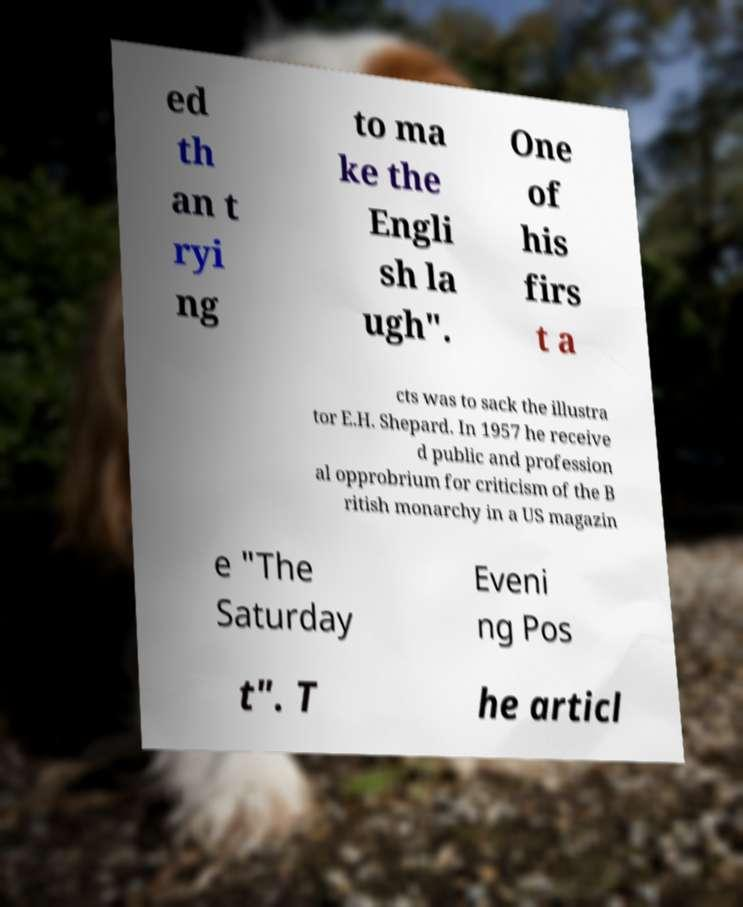Could you assist in decoding the text presented in this image and type it out clearly? ed th an t ryi ng to ma ke the Engli sh la ugh". One of his firs t a cts was to sack the illustra tor E.H. Shepard. In 1957 he receive d public and profession al opprobrium for criticism of the B ritish monarchy in a US magazin e "The Saturday Eveni ng Pos t". T he articl 